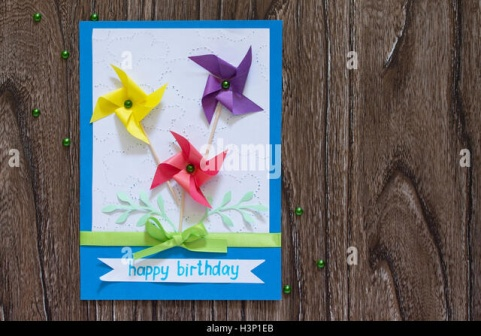If this birthday card could have a dialogue with the recipient, what would it say? Human: If this card could talk to its recipient, what would it say?

GPT: Hello there! I know it's your special day, and I was carefully crafted just for you! Each fold and each stroke of color carries a wish for your happiness. May these pinwheels spin joy into your life, and the green leaves remind you of growth and new adventures. The sparkling beads are here to sprinkle a little magic into your day. 'Happy Birthday!' is more than just a greeting; it's a heartfelt hug wrapped in paper. Celebrate with smiles, dance with delight, and know that you are cherished and loved. Enjoy every moment of your day and the wonderful year ahead! 